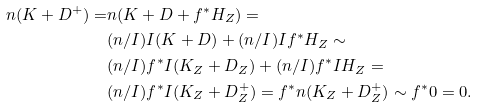Convert formula to latex. <formula><loc_0><loc_0><loc_500><loc_500>n ( K + D ^ { + } ) = & n ( K + D + f ^ { * } H _ { Z } ) = \\ & ( n / I ) I ( K + D ) + ( n / I ) I f ^ { * } H _ { Z } \sim \\ & ( n / I ) f ^ { * } I ( K _ { Z } + D _ { Z } ) + ( n / I ) f ^ { * } I H _ { Z } = \\ & ( n / I ) f ^ { * } I ( K _ { Z } + D _ { Z } ^ { + } ) = f ^ { * } n ( K _ { Z } + D _ { Z } ^ { + } ) \sim f ^ { * } 0 = 0 .</formula> 